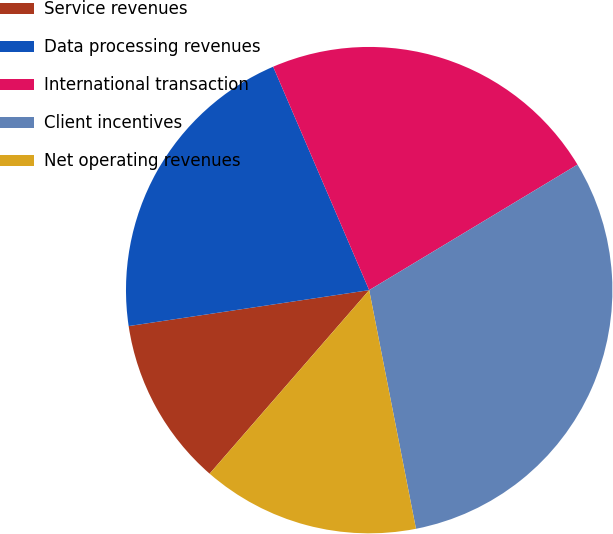<chart> <loc_0><loc_0><loc_500><loc_500><pie_chart><fcel>Service revenues<fcel>Data processing revenues<fcel>International transaction<fcel>Client incentives<fcel>Net operating revenues<nl><fcel>11.25%<fcel>20.9%<fcel>22.83%<fcel>30.55%<fcel>14.47%<nl></chart> 